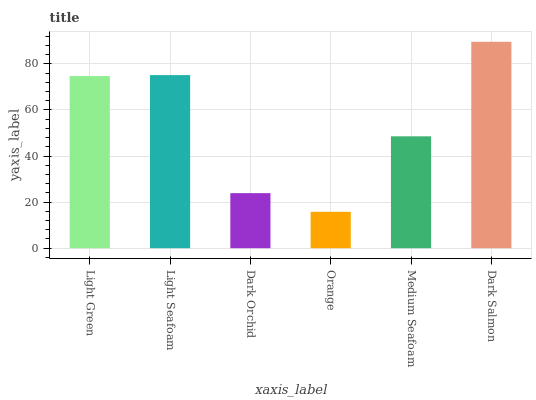Is Light Seafoam the minimum?
Answer yes or no. No. Is Light Seafoam the maximum?
Answer yes or no. No. Is Light Seafoam greater than Light Green?
Answer yes or no. Yes. Is Light Green less than Light Seafoam?
Answer yes or no. Yes. Is Light Green greater than Light Seafoam?
Answer yes or no. No. Is Light Seafoam less than Light Green?
Answer yes or no. No. Is Light Green the high median?
Answer yes or no. Yes. Is Medium Seafoam the low median?
Answer yes or no. Yes. Is Dark Salmon the high median?
Answer yes or no. No. Is Light Green the low median?
Answer yes or no. No. 